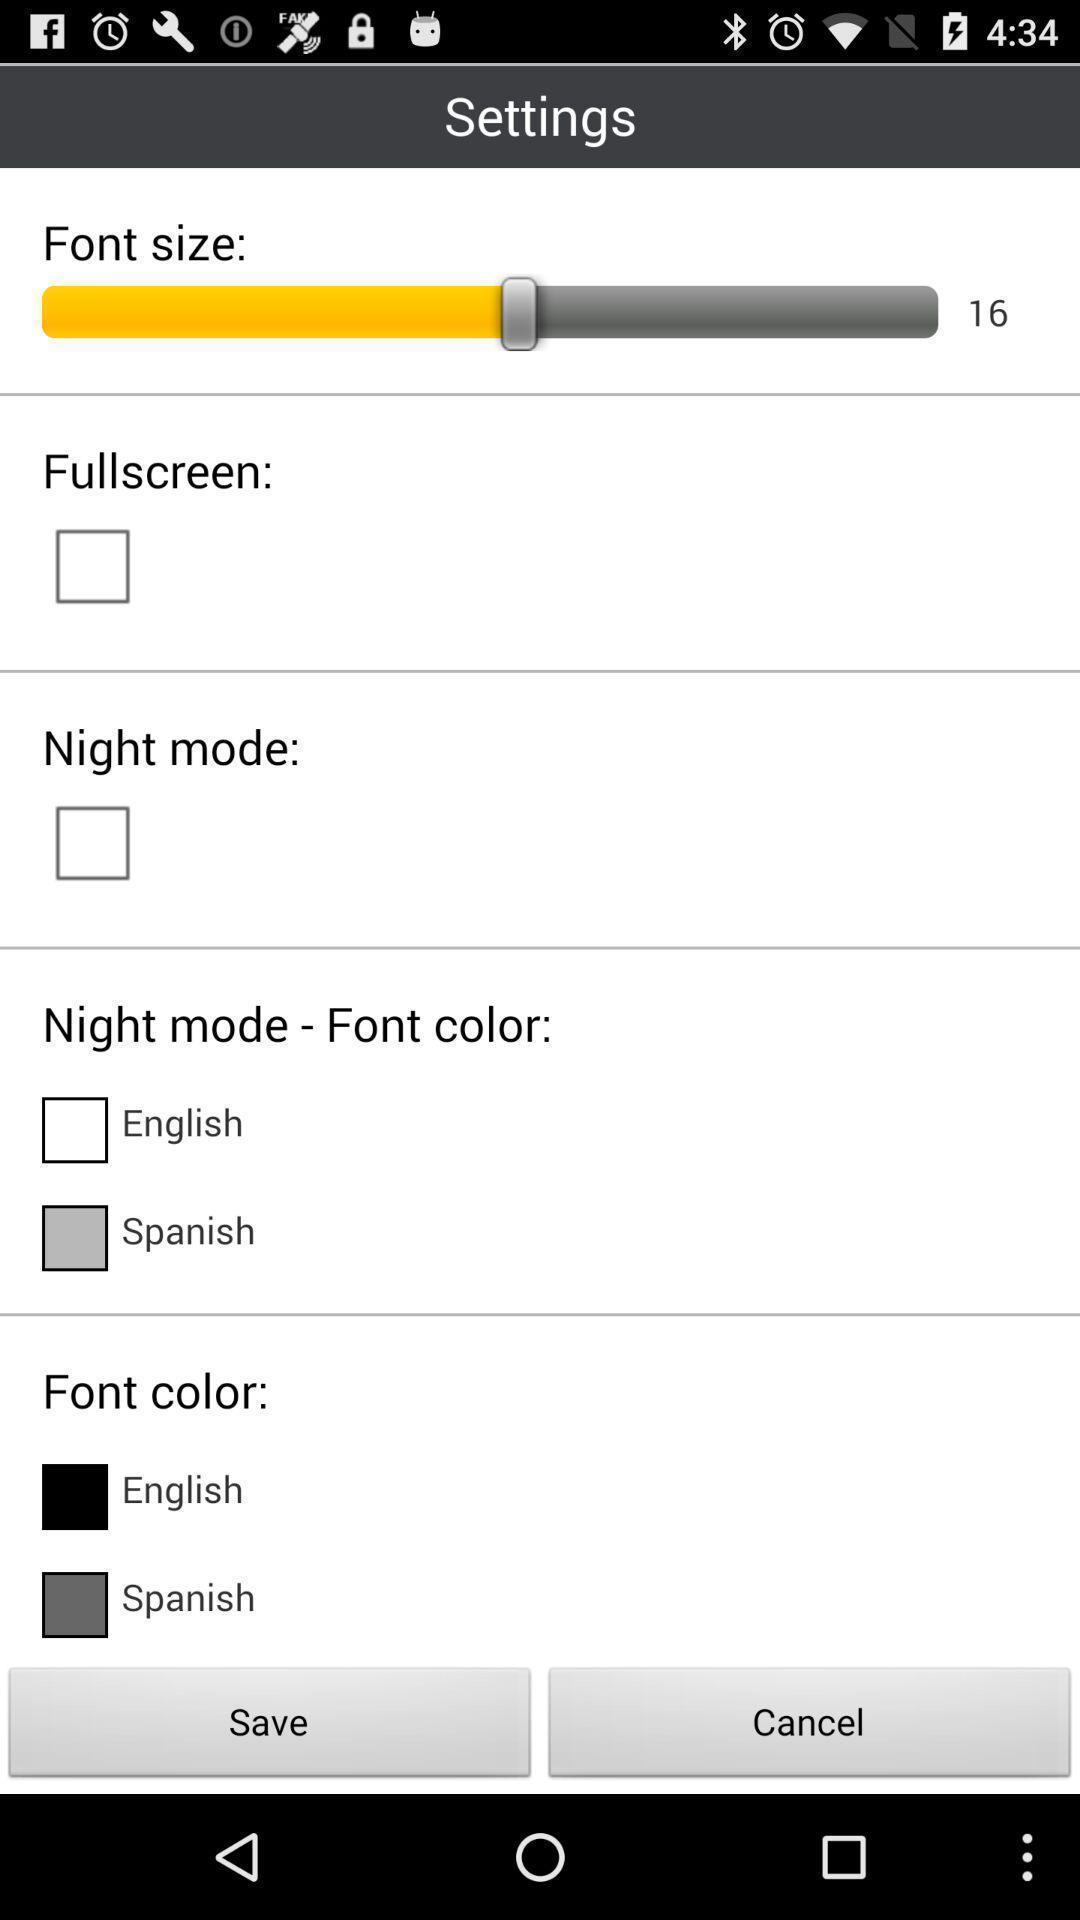Please provide a description for this image. Settings page. 